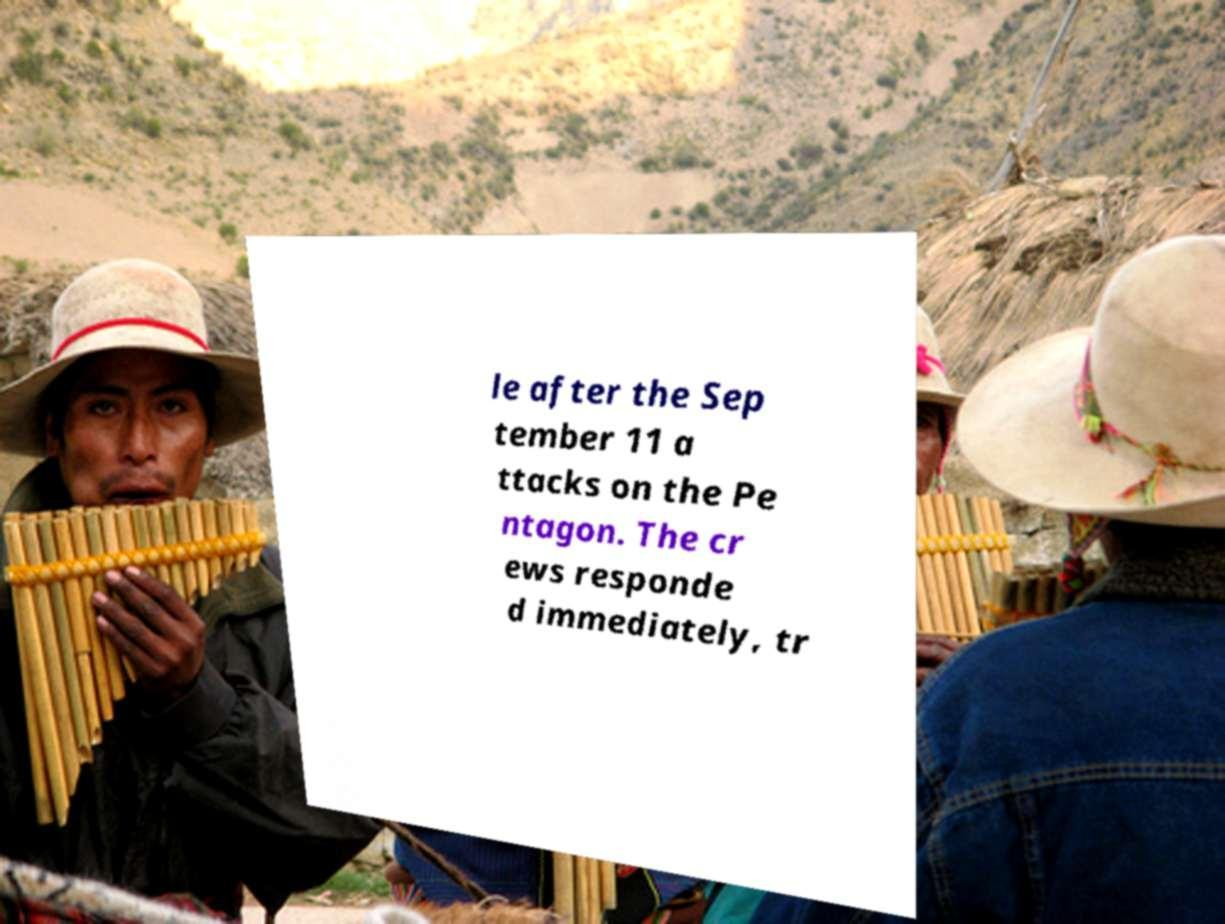I need the written content from this picture converted into text. Can you do that? le after the Sep tember 11 a ttacks on the Pe ntagon. The cr ews responde d immediately, tr 